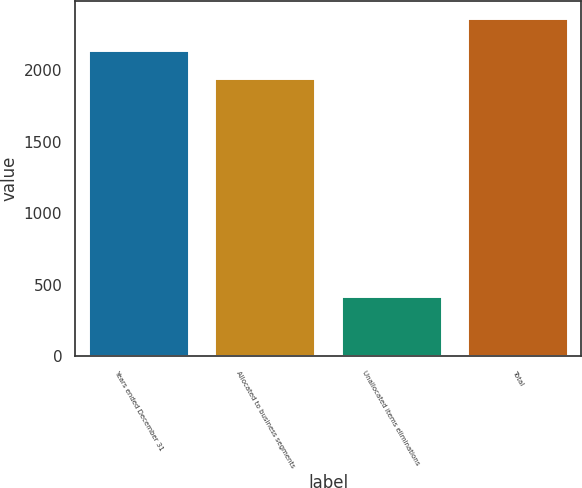Convert chart. <chart><loc_0><loc_0><loc_500><loc_500><bar_chart><fcel>Years ended December 31<fcel>Allocated to business segments<fcel>Unallocated items eliminations<fcel>Total<nl><fcel>2139.5<fcel>1945<fcel>421<fcel>2366<nl></chart> 